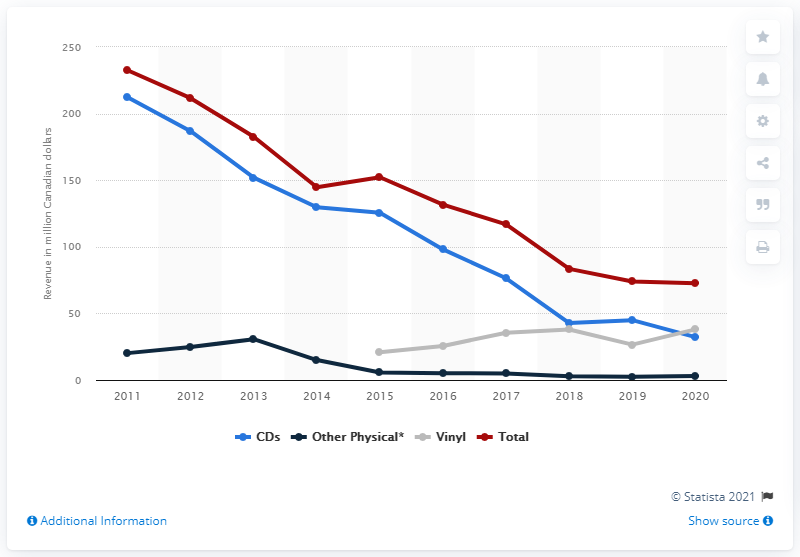Indicate a few pertinent items in this graphic. In 2020, the total amount of physical music revenue in Canada was CAD 72.7 million. The vinyl sales contributed 38.02% of the total revenue. 